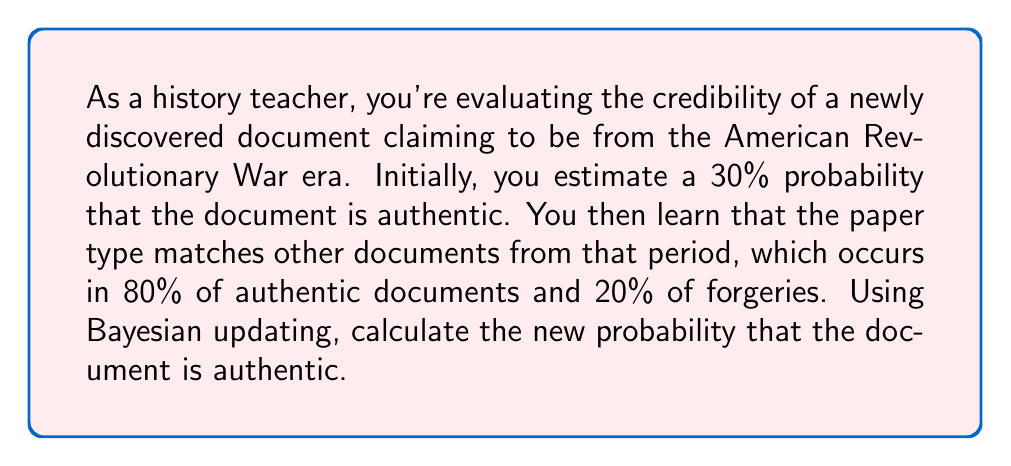Show me your answer to this math problem. Let's approach this problem using Bayes' theorem:

1) Define our events:
   A: The document is authentic
   E: The paper type matches the era

2) Given probabilities:
   P(A) = 0.30 (prior probability of authenticity)
   P(E|A) = 0.80 (probability of matching paper given authenticity)
   P(E|not A) = 0.20 (probability of matching paper given forgery)

3) Bayes' theorem formula:

   $$P(A|E) = \frac{P(E|A) \cdot P(A)}{P(E)}$$

4) Calculate P(E) using the law of total probability:
   
   $$P(E) = P(E|A) \cdot P(A) + P(E|not A) \cdot P(not A)$$
   $$P(E) = 0.80 \cdot 0.30 + 0.20 \cdot 0.70 = 0.24 + 0.14 = 0.38$$

5) Now apply Bayes' theorem:

   $$P(A|E) = \frac{0.80 \cdot 0.30}{0.38} = \frac{0.24}{0.38} \approx 0.6316$$

6) Convert to a percentage: 0.6316 * 100 ≈ 63.16%

Thus, after considering the new evidence, the probability that the document is authentic has increased from 30% to approximately 63.16%.
Answer: The new probability that the document is authentic is approximately 63.16%. 